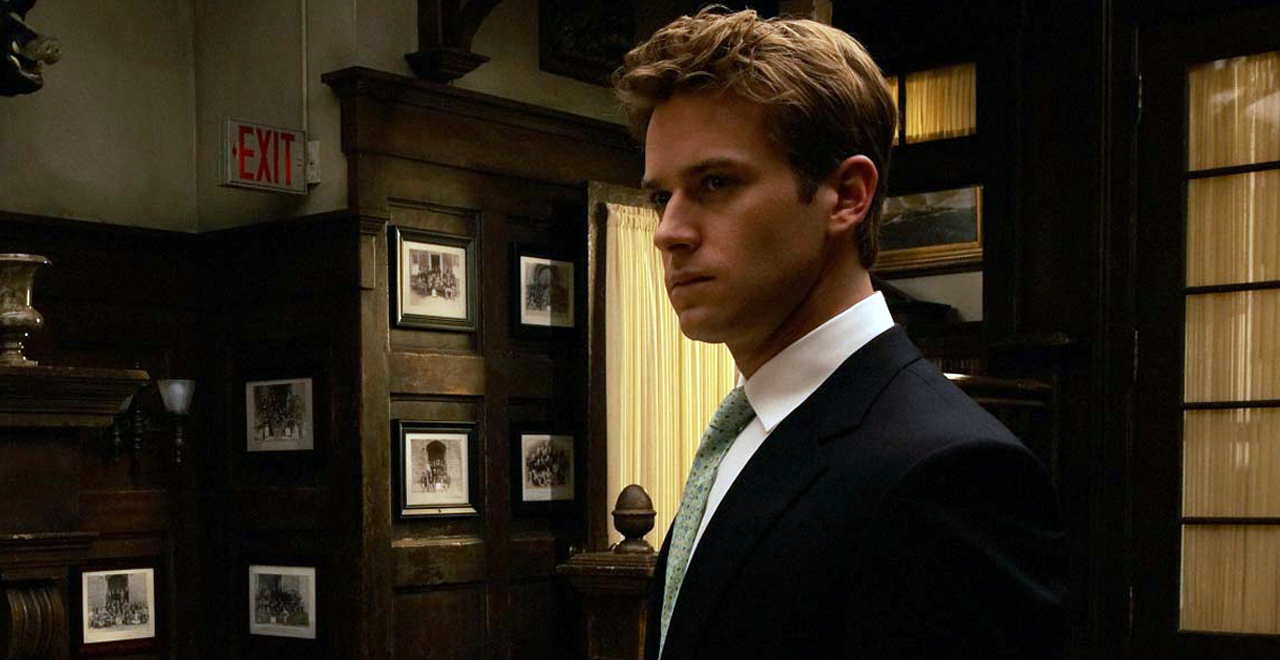What emotions does the character's expression convey? The character's expression conveys a mix of contemplation and seriousness. There's a hint of concern or deep thought, possibly reflecting a critical decision-making moment or an intense discussion he is mentally preparing for. 